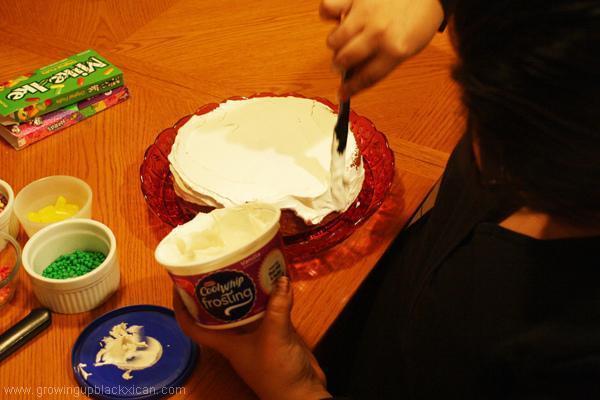How many bowls are in the picture?
Give a very brief answer. 3. 